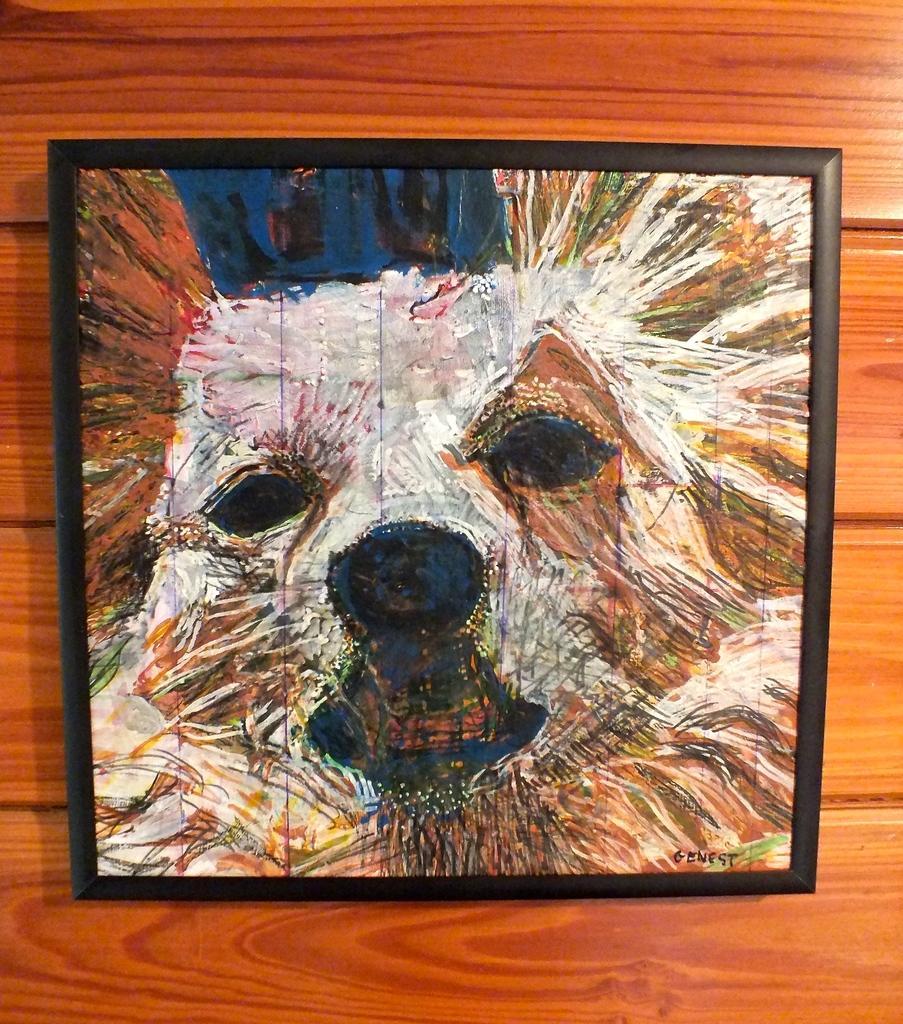Could you give a brief overview of what you see in this image? In this image I can see a dog painting frame. It is attached to the wooden wall. I can see colorful frame. 